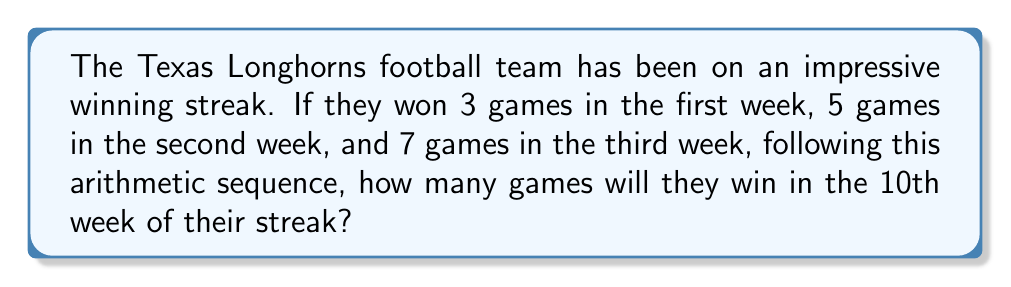Show me your answer to this math problem. Let's approach this step-by-step:

1) First, we need to identify the arithmetic sequence:
   Week 1: 3 games
   Week 2: 5 games
   Week 3: 7 games

2) In an arithmetic sequence, the difference between each term is constant. Let's call this common difference $d$:
   $d = 5 - 3 = 7 - 5 = 2$

3) The general formula for the nth term of an arithmetic sequence is:
   $a_n = a_1 + (n - 1)d$
   Where $a_n$ is the nth term, $a_1$ is the first term, $n$ is the position of the term, and $d$ is the common difference.

4) In this case:
   $a_1 = 3$ (first week's wins)
   $d = 2$ (common difference)
   $n = 10$ (we want the 10th week)

5) Let's substitute these values into our formula:
   $a_{10} = 3 + (10 - 1)2$
   $a_{10} = 3 + (9)2$
   $a_{10} = 3 + 18$
   $a_{10} = 21$

Therefore, in the 10th week of their winning streak, the Texas Longhorns will win 21 games.
Answer: 21 games 